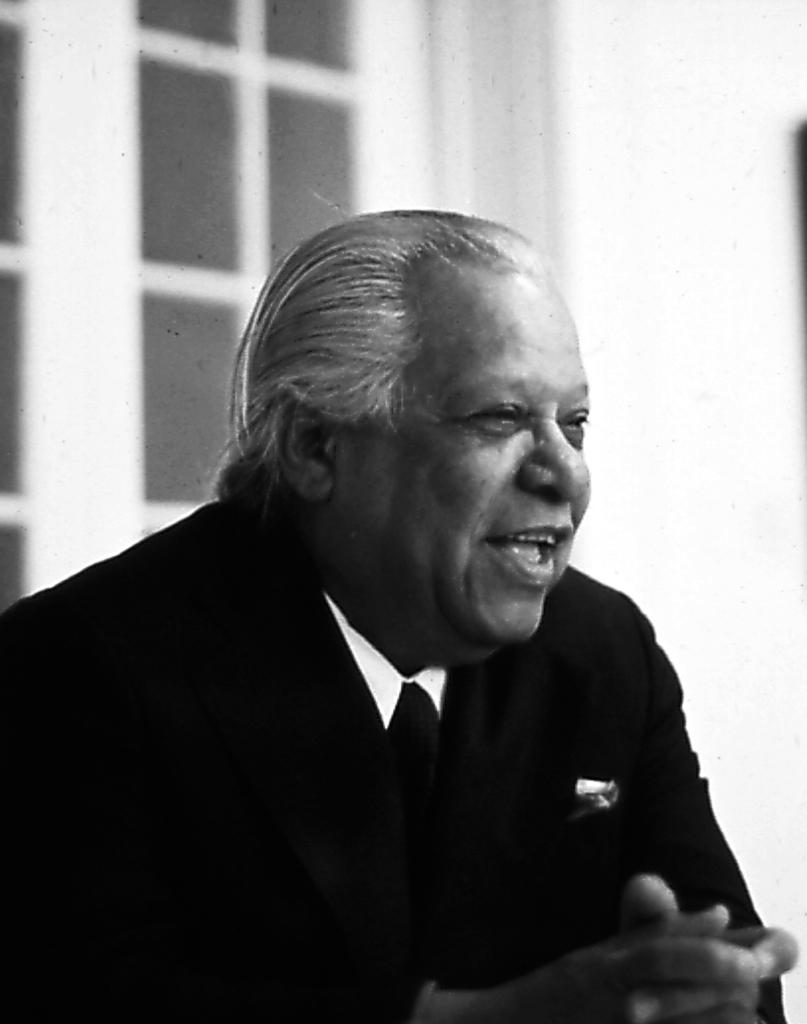What is the main subject in the foreground of the image? There is a person in the foreground of the image. What is the person doing in the image? The person is sitting. What is the person's facial expression in the image? The person is smiling. What can be seen in the background of the image? There is a window and a wall in the background of the image. What type of oven can be seen in the image? There is no oven present in the image. Is there a squirrel visible in the image? No, there is no squirrel visible in the image. 